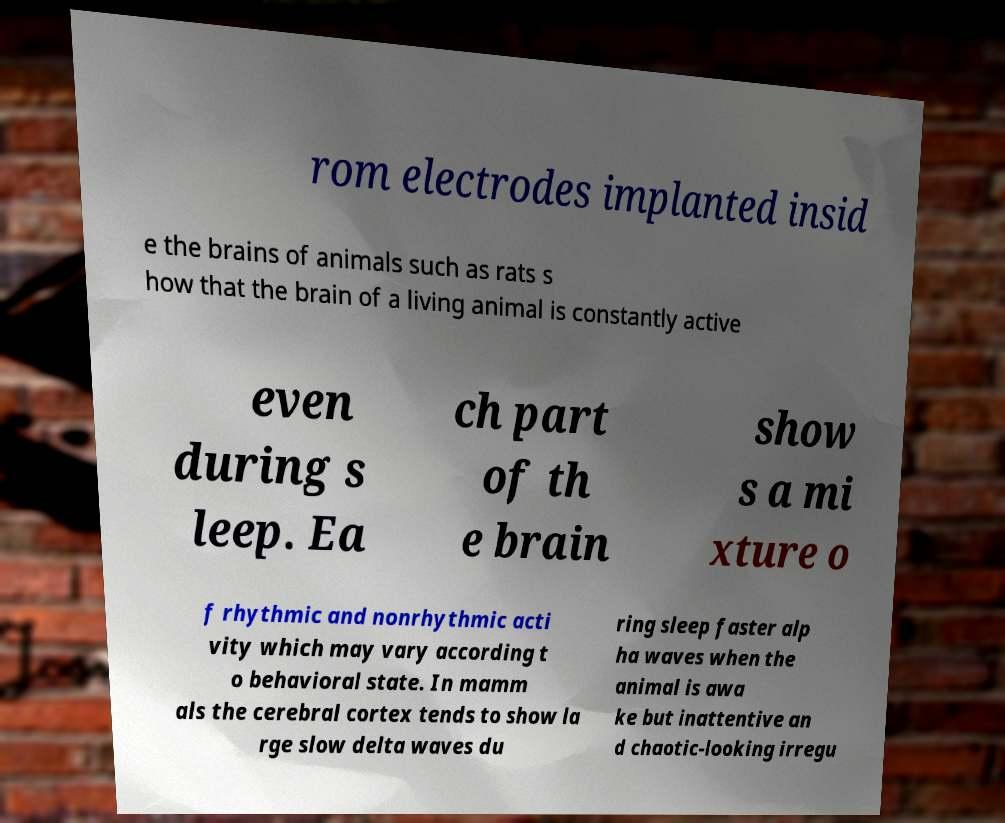There's text embedded in this image that I need extracted. Can you transcribe it verbatim? rom electrodes implanted insid e the brains of animals such as rats s how that the brain of a living animal is constantly active even during s leep. Ea ch part of th e brain show s a mi xture o f rhythmic and nonrhythmic acti vity which may vary according t o behavioral state. In mamm als the cerebral cortex tends to show la rge slow delta waves du ring sleep faster alp ha waves when the animal is awa ke but inattentive an d chaotic-looking irregu 